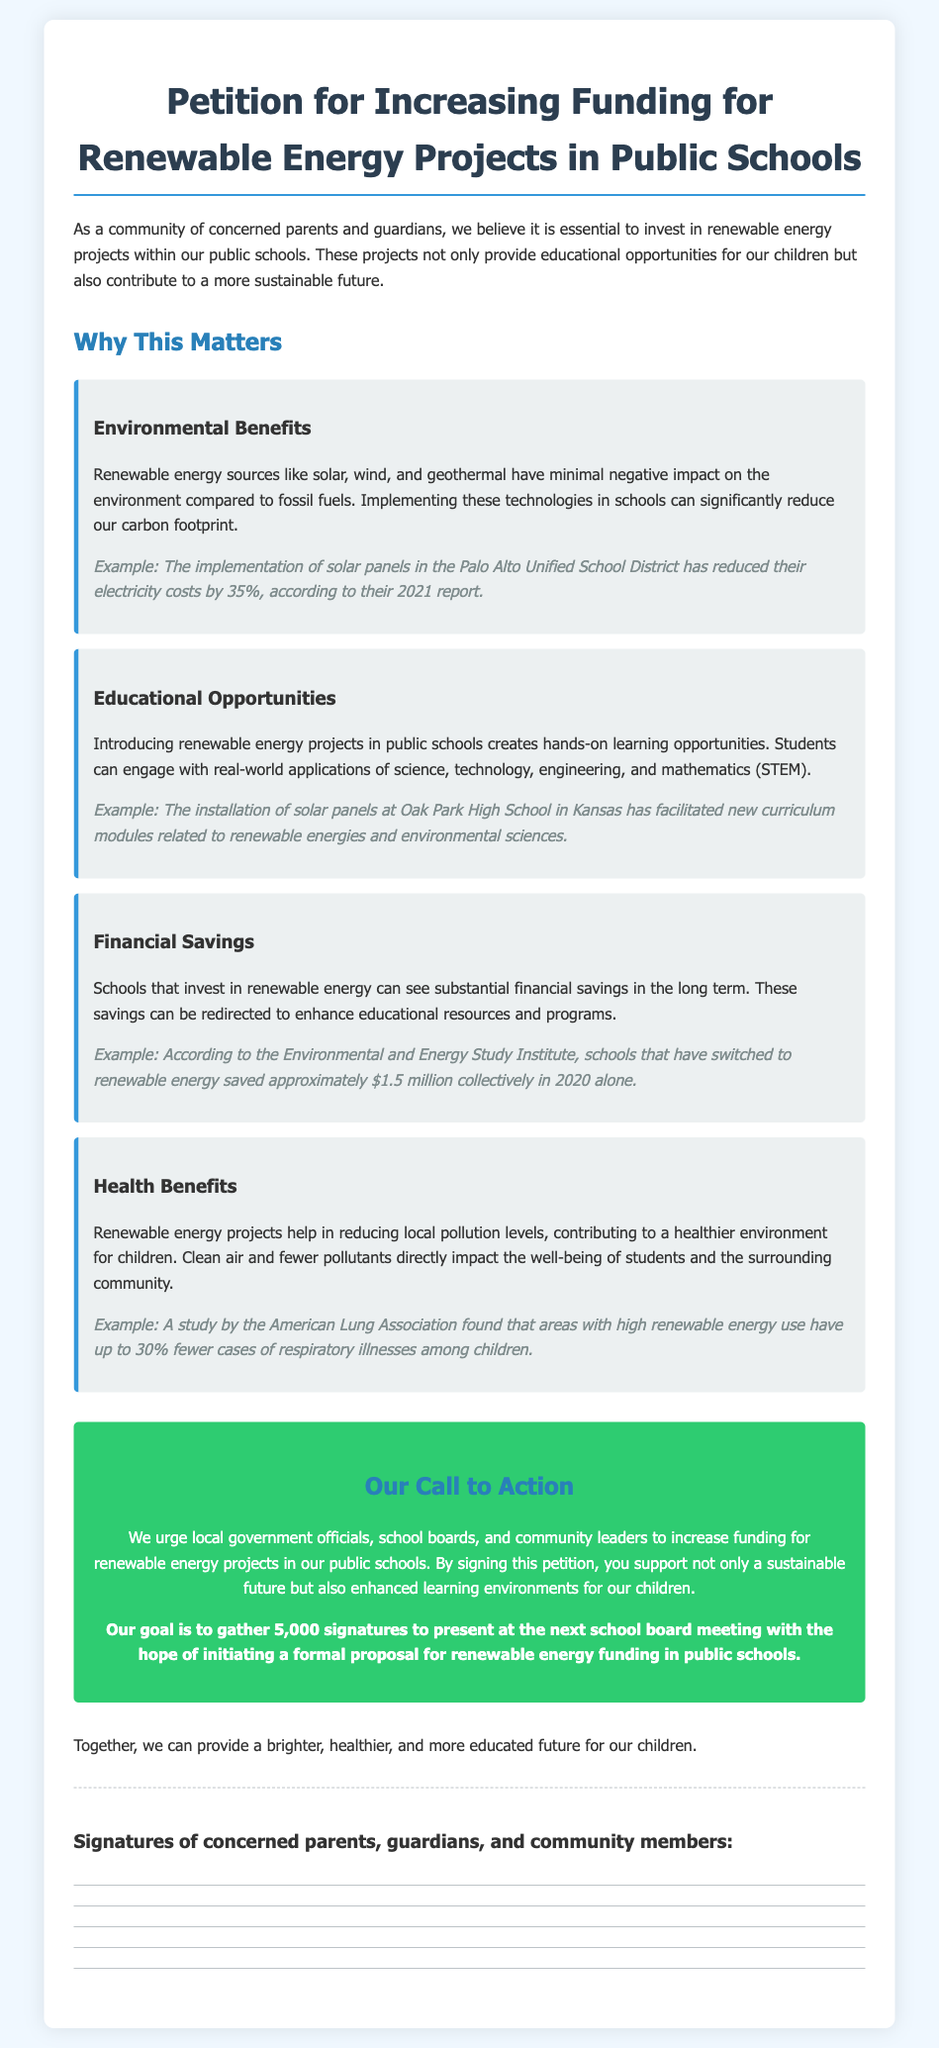What is the title of the petition? The title is prominently displayed at the top of the document, which is focused on renewable energy projects in schools.
Answer: Petition for Increasing Funding for Renewable Energy Projects in Public Schools What is the goal of the petition? The goal is mentioned in the call to action section, delineating the aim of the petition clearly.
Answer: Gather 5,000 signatures What are the first two renewable energy sources mentioned? These sources are listed under environmental benefits, showcasing the types of energy the petition advocates for.
Answer: Solar, wind What year is cited in the Palo Alto Unified School District example? The example includes a specific report from a given year to support its claim about cost reduction.
Answer: 2021 How much money did schools save collectively in 2020? This financial saving figure is cited as a compelling reason for funding renewable energy projects.
Answer: $1.5 million Who conducted a study that found areas with high renewable energy use have fewer respiratory illnesses? This information connects a reputable organization to a health benefit described in the document.
Answer: American Lung Association What color is used for the call to action section? The background color of this section indicates its importance and urgency visually.
Answer: Green What can the substantial savings from renewable energy be redirected towards? This is indicated in the financial benefits section, aligning with the educational goals of the petition.
Answer: Educational resources and programs 